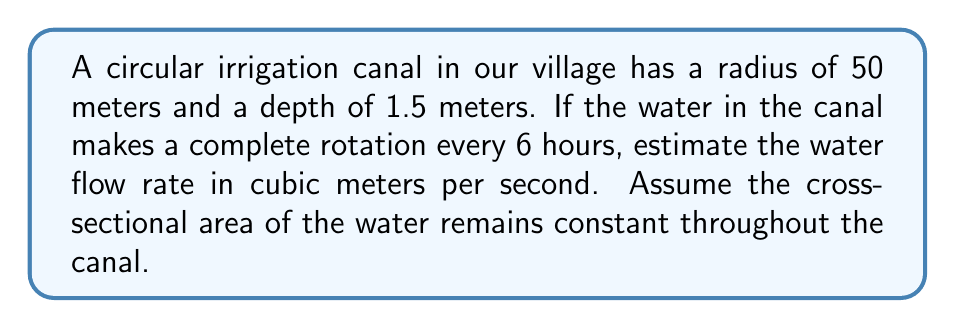Teach me how to tackle this problem. Let's approach this problem step-by-step:

1) First, we need to calculate the cross-sectional area of the canal:
   $A = \text{width} \times \text{depth}$
   The width is the diameter of the canal: $2 \times 50 = 100$ meters
   $A = 100 \text{ m} \times 1.5 \text{ m} = 150 \text{ m}^2$

2) Now, let's calculate the volume of water in the entire canal:
   $V = A \times \text{circumference}$
   Circumference $= 2\pi r = 2\pi \times 50 = 100\pi \text{ m}$
   $V = 150 \text{ m}^2 \times 100\pi \text{ m} = 15000\pi \text{ m}^3$

3) The water makes a complete rotation every 6 hours, which is 21600 seconds.
   So, the flow rate $Q$ in $\text{m}^3/\text{s}$ is:

   $$Q = \frac{V}{t} = \frac{15000\pi \text{ m}^3}{21600 \text{ s}} \approx 2.18 \text{ m}^3/\text{s}$$

4) Rounding to two decimal places for a reasonable estimate:
   $Q \approx 2.18 \text{ m}^3/\text{s}$
Answer: $2.18 \text{ m}^3/\text{s}$ 